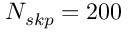<formula> <loc_0><loc_0><loc_500><loc_500>N _ { s k p } = 2 0 0</formula> 